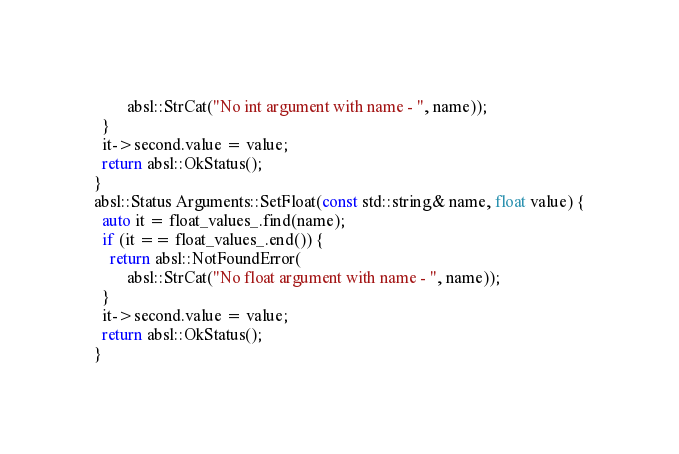Convert code to text. <code><loc_0><loc_0><loc_500><loc_500><_C++_>        absl::StrCat("No int argument with name - ", name));
  }
  it->second.value = value;
  return absl::OkStatus();
}
absl::Status Arguments::SetFloat(const std::string& name, float value) {
  auto it = float_values_.find(name);
  if (it == float_values_.end()) {
    return absl::NotFoundError(
        absl::StrCat("No float argument with name - ", name));
  }
  it->second.value = value;
  return absl::OkStatus();
}
</code> 